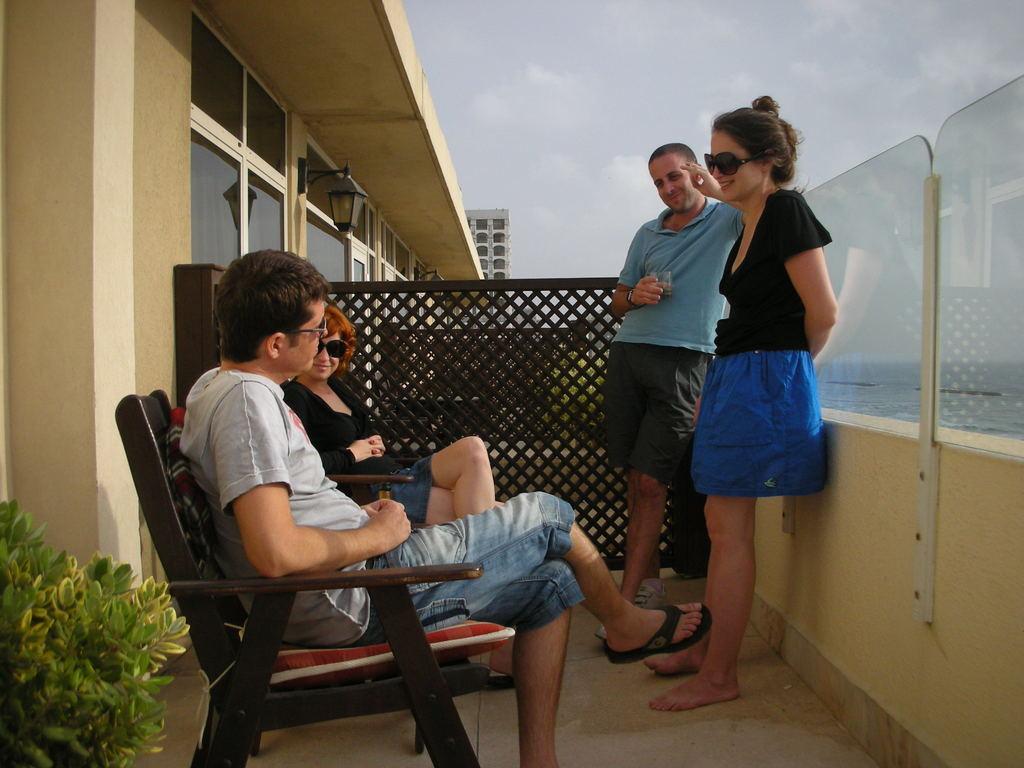Can you describe this image briefly? In this picture we can see a plant, two people sitting on chairs and in front of them we can see two people standing on the floor, fences, buildings, lamps, wall and some objects and in the background we can see the sky. 